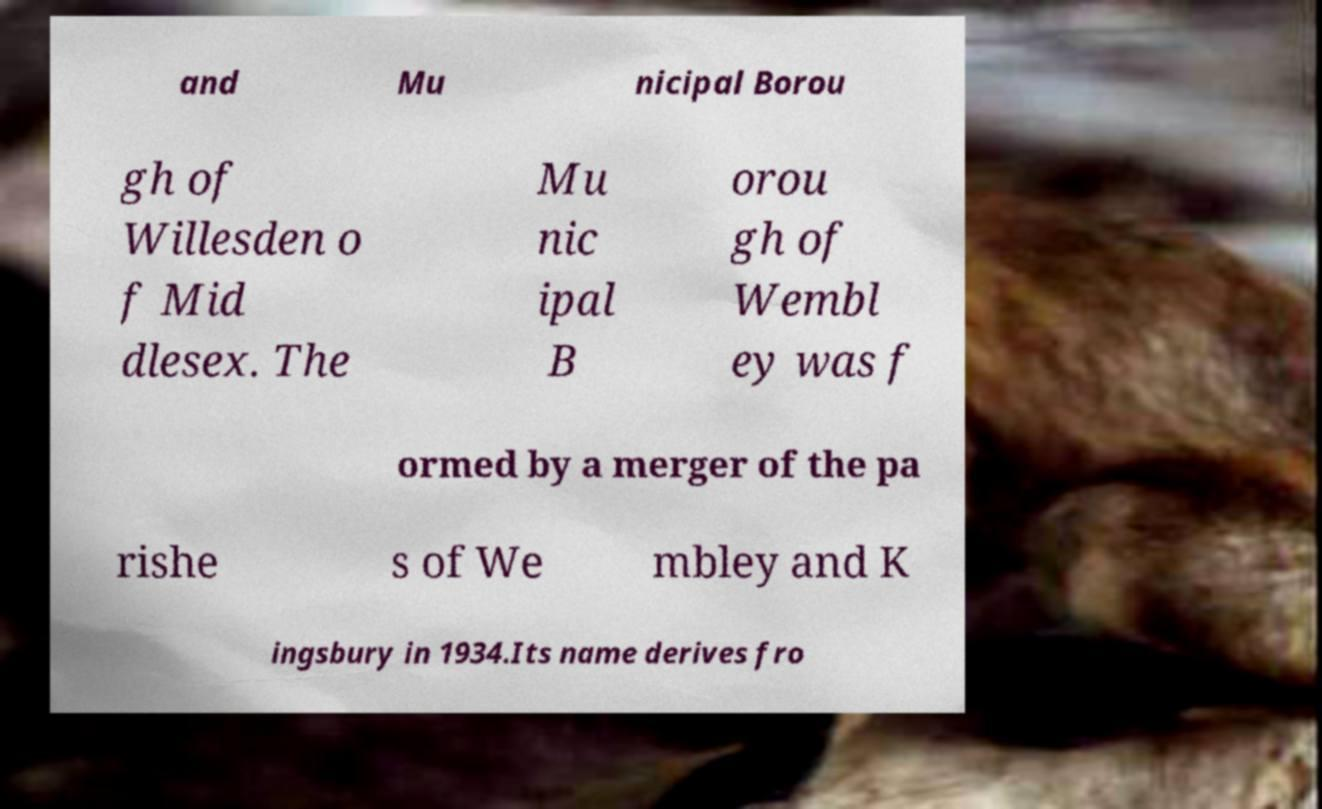Could you assist in decoding the text presented in this image and type it out clearly? and Mu nicipal Borou gh of Willesden o f Mid dlesex. The Mu nic ipal B orou gh of Wembl ey was f ormed by a merger of the pa rishe s of We mbley and K ingsbury in 1934.Its name derives fro 